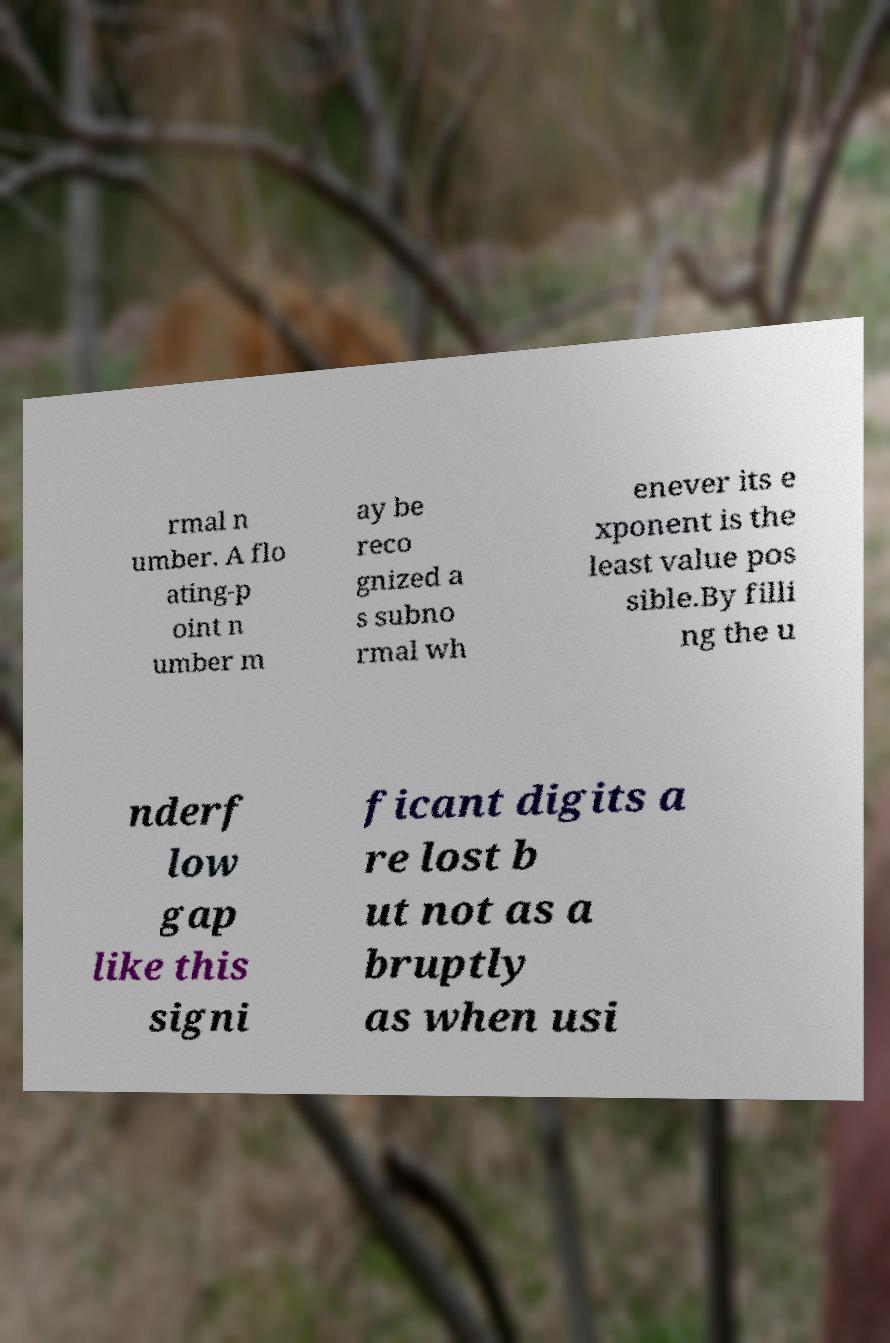For documentation purposes, I need the text within this image transcribed. Could you provide that? rmal n umber. A flo ating-p oint n umber m ay be reco gnized a s subno rmal wh enever its e xponent is the least value pos sible.By filli ng the u nderf low gap like this signi ficant digits a re lost b ut not as a bruptly as when usi 